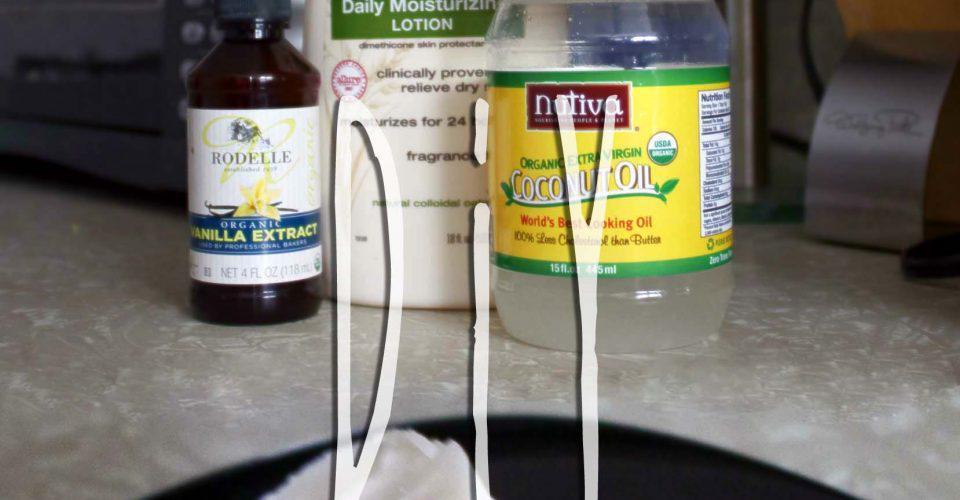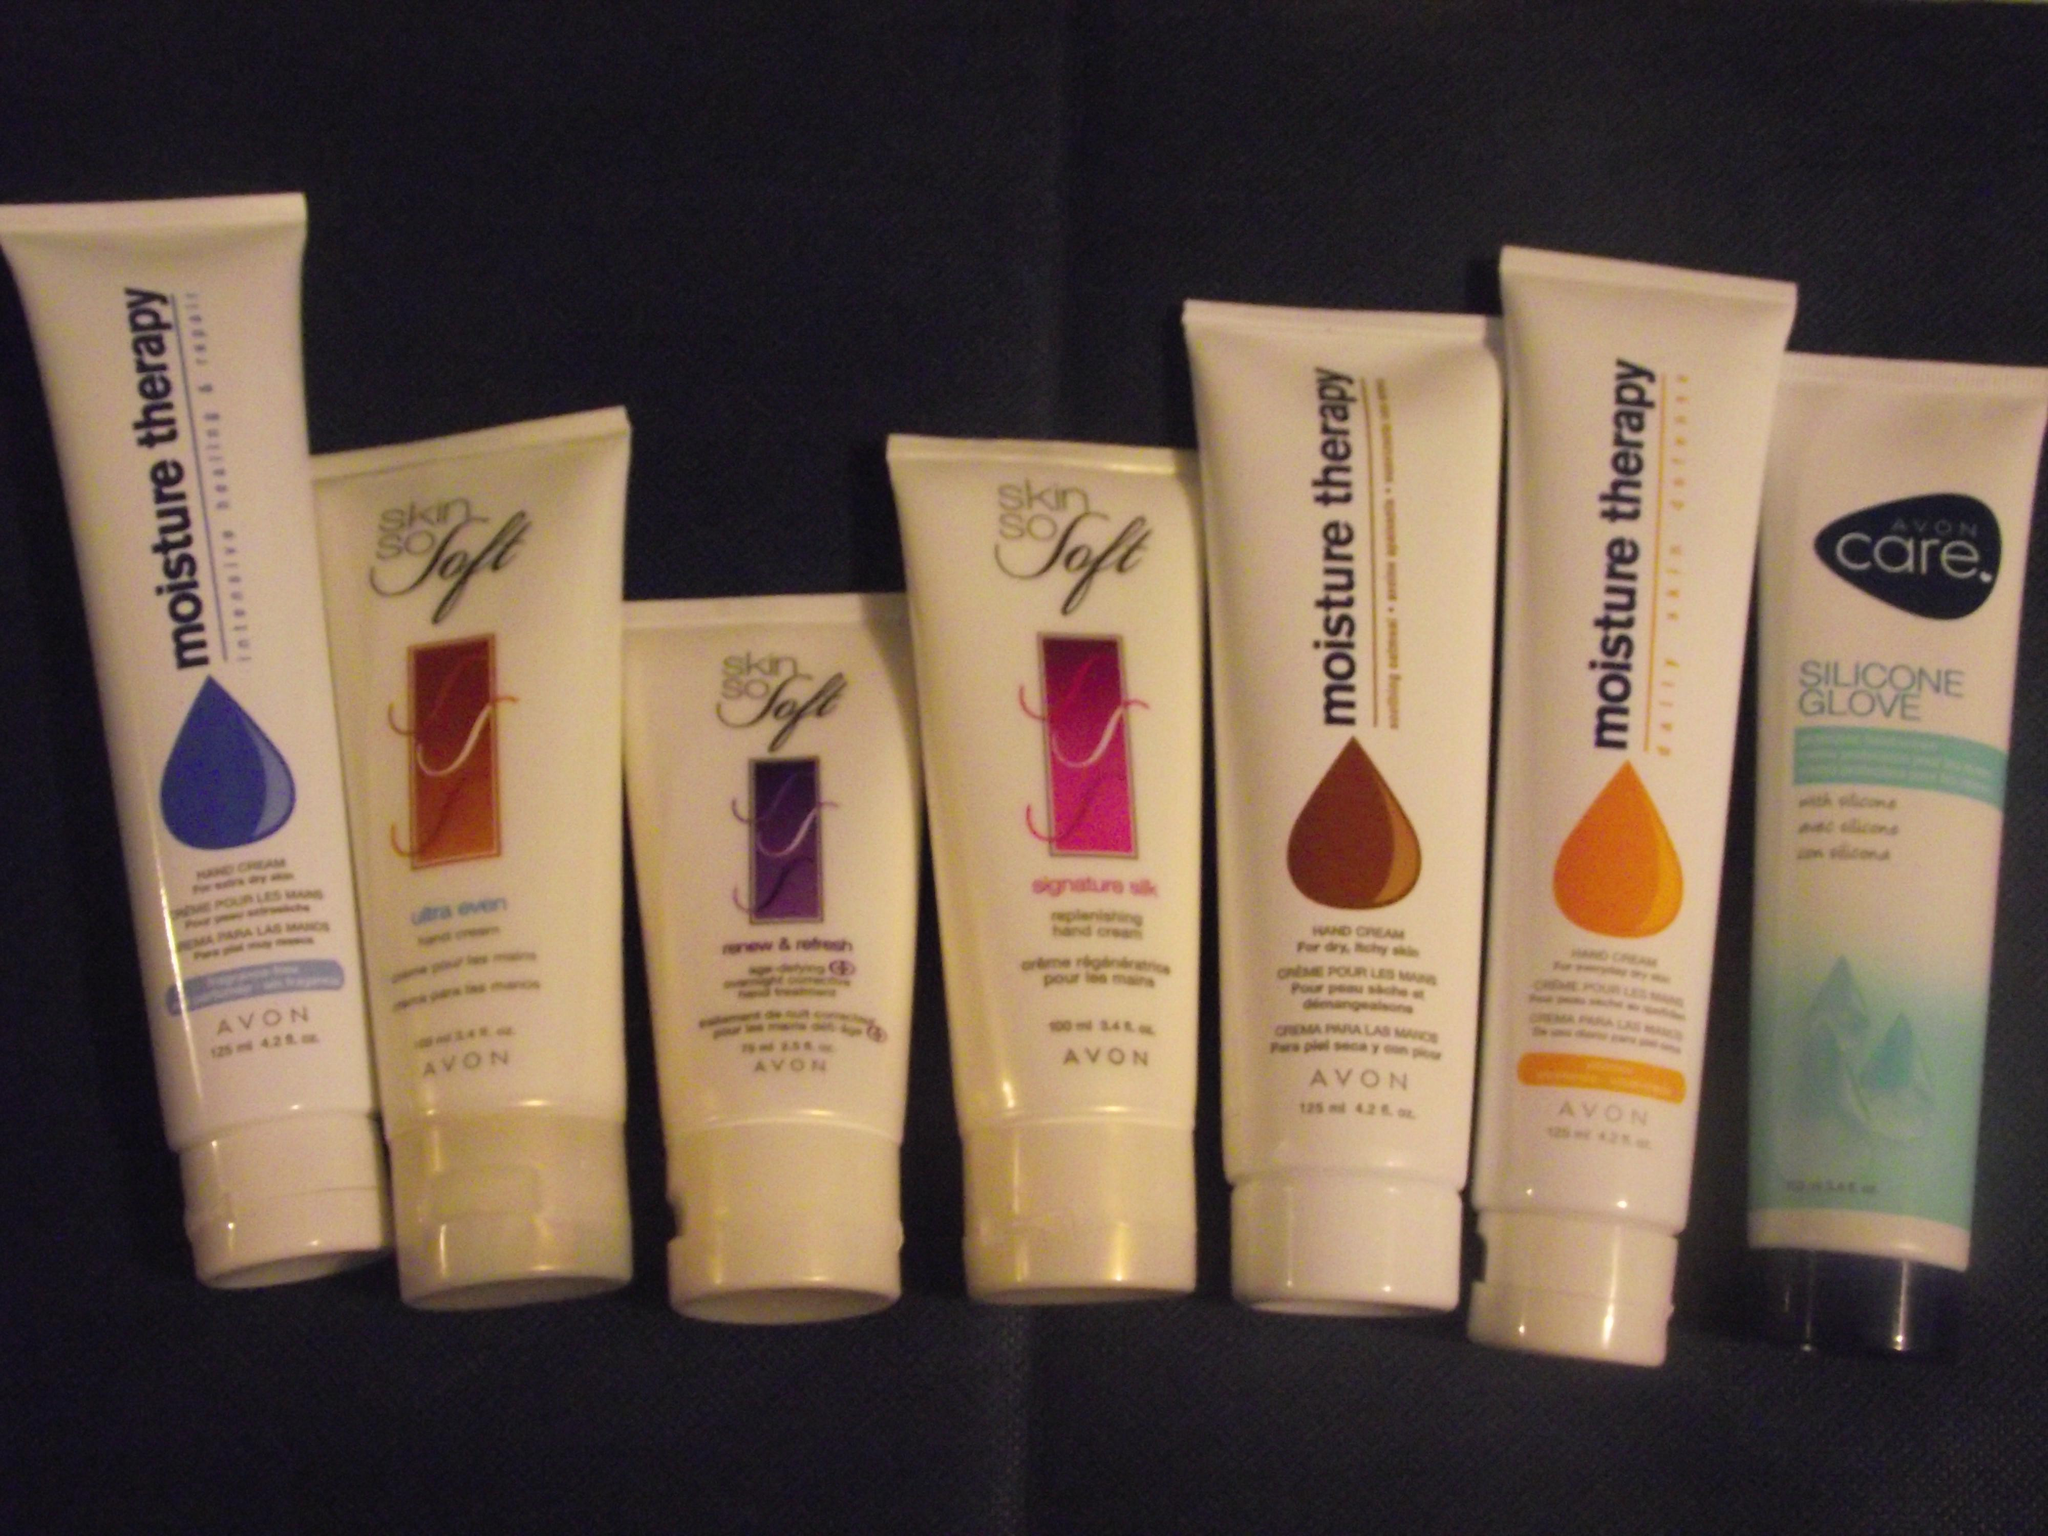The first image is the image on the left, the second image is the image on the right. Examine the images to the left and right. Is the description "An image shows only pump-top products." accurate? Answer yes or no. No. The first image is the image on the left, the second image is the image on the right. Analyze the images presented: Is the assertion "Two bottles of lotion stand together in the image on the left." valid? Answer yes or no. No. 